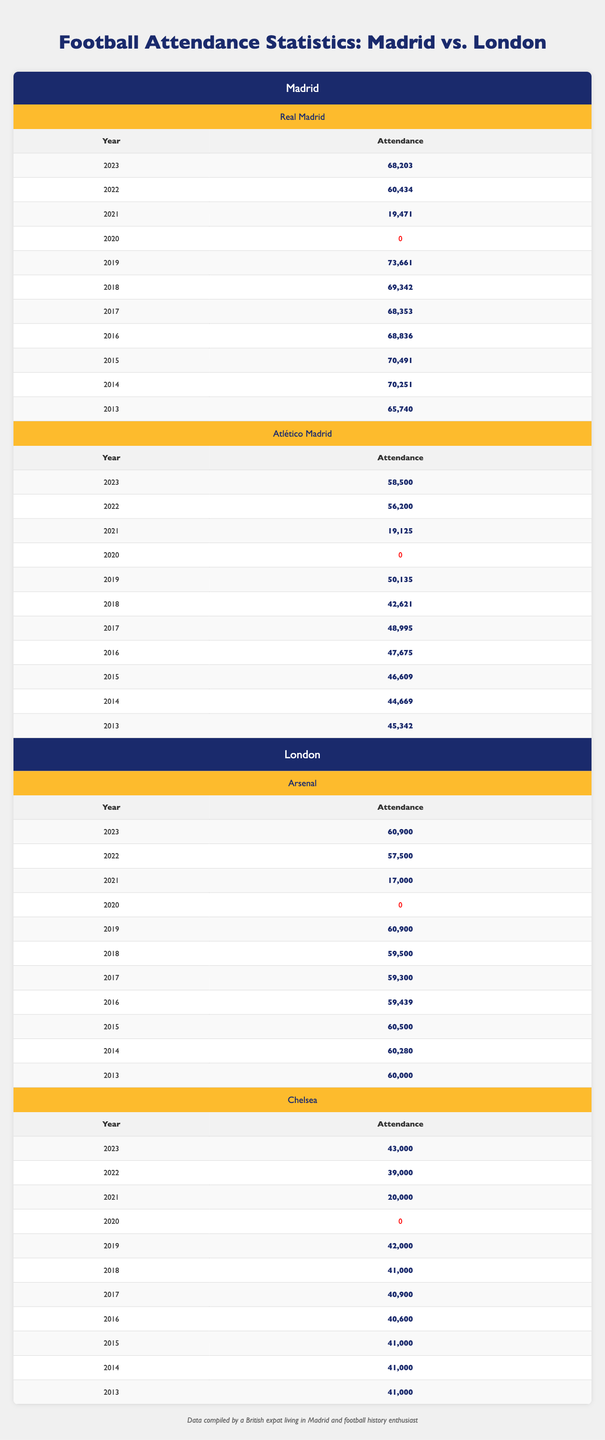What was the attendance of Real Madrid in 2019? The table shows that for the year 2019, Real Madrid had an attendance of 73,661.
Answer: 73,661 What was the lowest attendance of Atlético Madrid over the last decade? By looking at the Atlético Madrid data, the lowest attendance recorded was 19,125 in 2021.
Answer: 19,125 Which London club had a higher attendance in 2023, Arsenal or Chelsea? In 2023, Arsenal had an attendance of 60,900 while Chelsea had 43,000. Since 60,900 is greater than 43,000, Arsenal had a higher attendance.
Answer: Arsenal What is the average attendance for Chelsea from 2013 to 2023? First, sum up all the attendances: 41,000 + 41,000 + 41,000 + 40,600 + 40,900 + 41,000 + 42,000 + 0 + 20,000 + 39,000 + 43,000 = 392,600. Divide that by the number of years, which is 11: 392,600 / 11 = 35,600.
Answer: 35,600 Was there any year in which both Madrid clubs recorded zero attendance? Looking at the data, both clubs had zero attendance in the year 2020, indicating there was indeed a year with zero attendance for both.
Answer: Yes Which club had the most consistent attendance figures over the years? To determine consistency, we can look for smaller fluctuations in attendance. Real Madrid's attendance varied between a range of 19,471 to 73,661 with only one year less than 20,000, while Atlético Madrid had more years with attendance below 20,000. Therefore, Real Madrid appears to have the most consistent attendance figures.
Answer: Real Madrid What year had the highest attendance for London clubs combined? To find this, sum the highest attendances each club got in the same year, for instance, 2019: Arsenal (60,900) + Chelsea (42,000) = 102,900. Evaluating other years reveals that 2019 also had the highest combination for both clubs.
Answer: 102,900 How much has the attendance of Atlético Madrid changed from 2019 to 2023? For Atlético Madrid, the attendance in 2019 was 50,135 and in 2023 was 58,500. To find the change: 58,500 - 50,135 = 8,365. Thus, the attendance increased by 8,365.
Answer: 8,365 